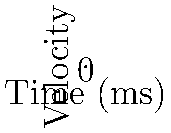Analyze the velocity-time graphs representing motion in VR at different frame rates. How does the higher frame rate (60 FPS) impact the perceived smoothness of motion compared to the lower frame rate (30 FPS), and what implications does this have for immersion in virtual reality environments? To understand the impact of frame rates on perceived motion in VR, let's analyze the graphs step-by-step:

1. Graph interpretation:
   - Blue line: 60 FPS (Frames Per Second)
   - Red line: 30 FPS

2. Frequency of updates:
   - 60 FPS updates every 16.67 ms ($$\frac{1000 \text{ ms}}{60 \text{ frames}} \approx 16.67 \text{ ms}$$)
   - 30 FPS updates every 33.33 ms ($$\frac{1000 \text{ ms}}{30 \text{ frames}} \approx 33.33 \text{ ms}$$)

3. Smoothness of motion:
   - 60 FPS line has more data points and a smoother curve
   - 30 FPS line has fewer data points and appears more jagged

4. Temporal resolution:
   - 60 FPS provides twice the temporal resolution of 30 FPS
   - This results in more accurate representation of motion over time

5. Motion perception:
   - Human visual system can detect changes faster than 30 Hz
   - 60 FPS is closer to the limits of human perception, appearing more fluid

6. Reduction of motion artifacts:
   - Higher frame rate reduces motion blur and stuttering
   - This is crucial for maintaining the illusion of continuous motion in VR

7. Implications for VR immersion:
   - Smoother motion enhances the sense of presence in virtual environments
   - Reduces the risk of motion sickness by minimizing visual-vestibular conflicts

8. Cognitive load:
   - Smoother motion requires less cognitive processing to interpret
   - This allows users to focus more on the content rather than visual artifacts

The higher frame rate (60 FPS) provides a more accurate and smoother representation of motion, which is crucial for creating a more immersive and comfortable VR experience.
Answer: 60 FPS provides smoother, more accurate motion representation, enhancing immersion and reducing motion artifacts in VR environments. 